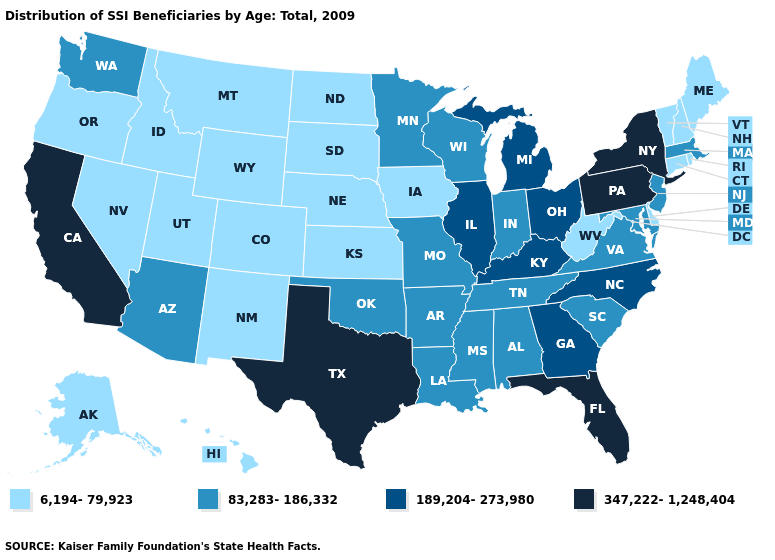Name the states that have a value in the range 347,222-1,248,404?
Answer briefly. California, Florida, New York, Pennsylvania, Texas. Does South Dakota have the lowest value in the MidWest?
Give a very brief answer. Yes. What is the lowest value in the Northeast?
Concise answer only. 6,194-79,923. What is the lowest value in the Northeast?
Answer briefly. 6,194-79,923. What is the value of California?
Give a very brief answer. 347,222-1,248,404. Among the states that border Pennsylvania , does New York have the highest value?
Write a very short answer. Yes. Among the states that border West Virginia , which have the lowest value?
Answer briefly. Maryland, Virginia. Name the states that have a value in the range 6,194-79,923?
Quick response, please. Alaska, Colorado, Connecticut, Delaware, Hawaii, Idaho, Iowa, Kansas, Maine, Montana, Nebraska, Nevada, New Hampshire, New Mexico, North Dakota, Oregon, Rhode Island, South Dakota, Utah, Vermont, West Virginia, Wyoming. Does the first symbol in the legend represent the smallest category?
Be succinct. Yes. What is the value of Mississippi?
Quick response, please. 83,283-186,332. What is the value of Colorado?
Answer briefly. 6,194-79,923. Among the states that border Rhode Island , which have the highest value?
Concise answer only. Massachusetts. Does Nebraska have a higher value than Connecticut?
Concise answer only. No. Does Hawaii have a lower value than Illinois?
Quick response, please. Yes. Name the states that have a value in the range 83,283-186,332?
Be succinct. Alabama, Arizona, Arkansas, Indiana, Louisiana, Maryland, Massachusetts, Minnesota, Mississippi, Missouri, New Jersey, Oklahoma, South Carolina, Tennessee, Virginia, Washington, Wisconsin. 